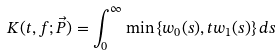Convert formula to latex. <formula><loc_0><loc_0><loc_500><loc_500>K ( t , f ; \vec { P } ) = \int _ { 0 } ^ { \infty } \min \left \{ w _ { 0 } ( s ) , t w _ { 1 } ( s ) \right \} d s</formula> 